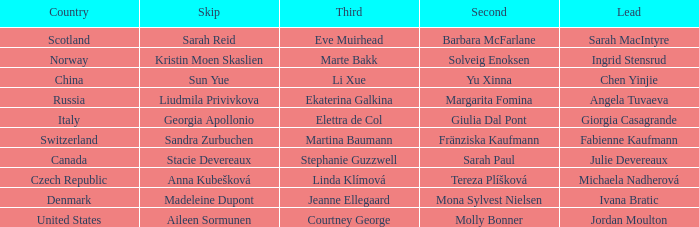In which skip is angela tuvaeva the main character? Liudmila Privivkova. 